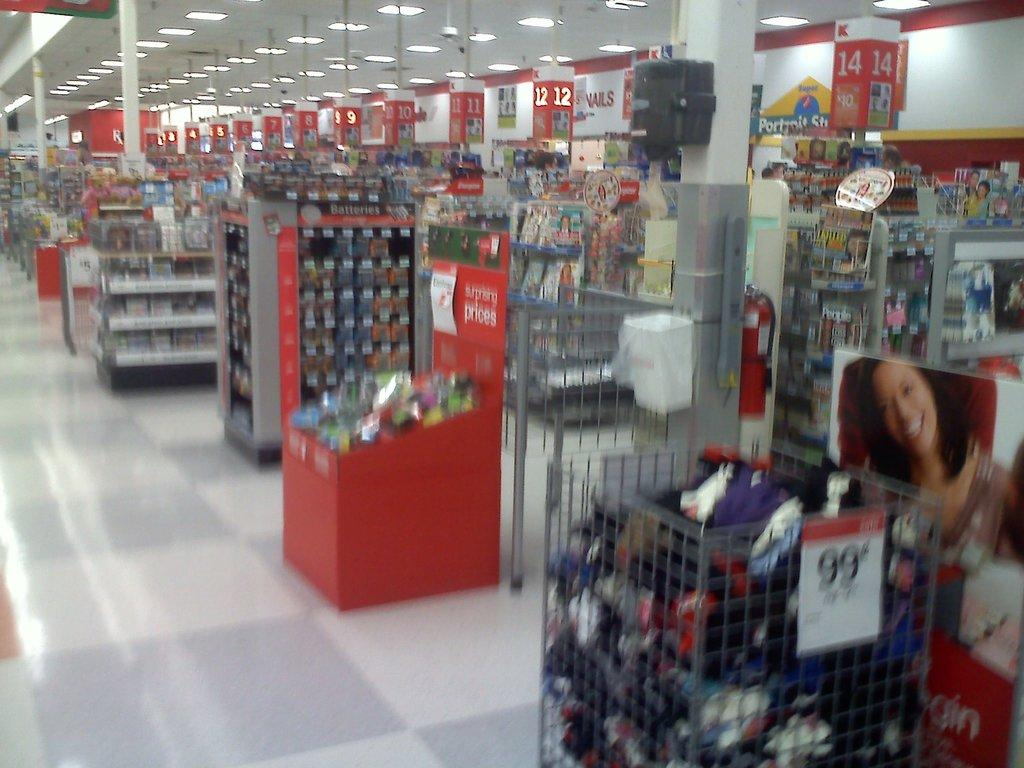Where was the image taken? The image was taken in a supermarket. What type of furniture can be seen in the image? There are cupboards in the image. What type of decorations are present in the image? There are posters in the image. What type of information is present in the image? Numbers are present in the image. What type of illumination is visible in the image? Lights are visible in the image. What type of signage is present in the image? Name boards are in the image. What other objects can be seen in the image? There are other objects in the image. What is the main feature in the foreground of the image? The foreground of the image is a well. What is the size of the tree in the image? There is no tree present in the image. 